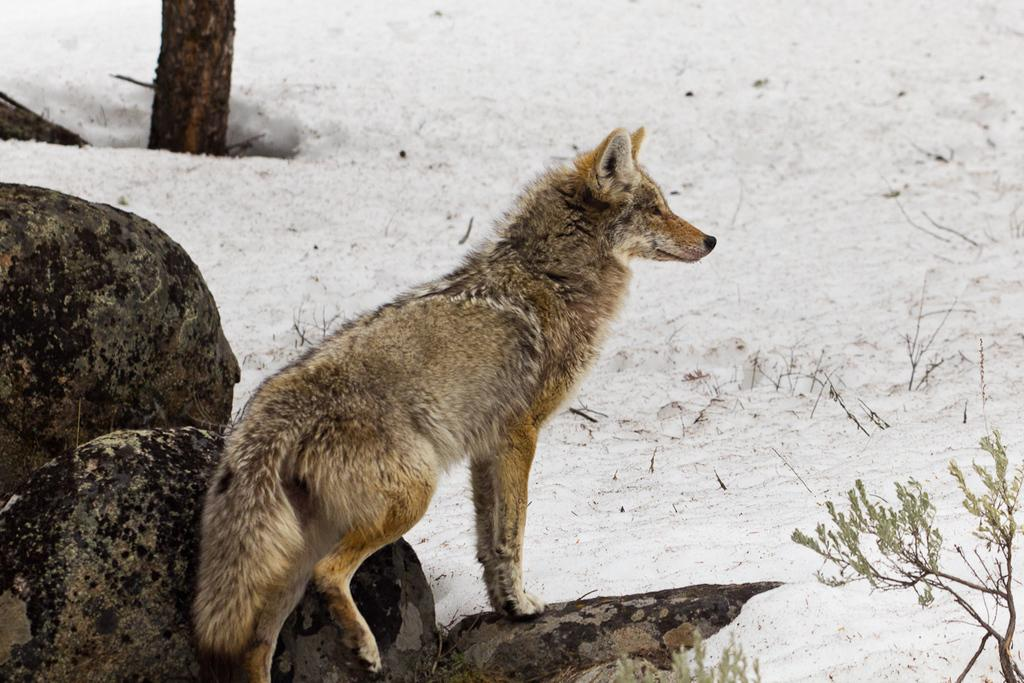What type of animal can be seen in the image? There is an animal in the image, but its specific type cannot be determined from the facts provided. What is the animal standing on? The animal is standing on a rock. What can be seen in the background of the image? There is a tree, snow, and plants visible in the background of the image. What does the caption say about the rat in the image? There is no caption present in the image, and there is no mention of a rat in the provided facts. 